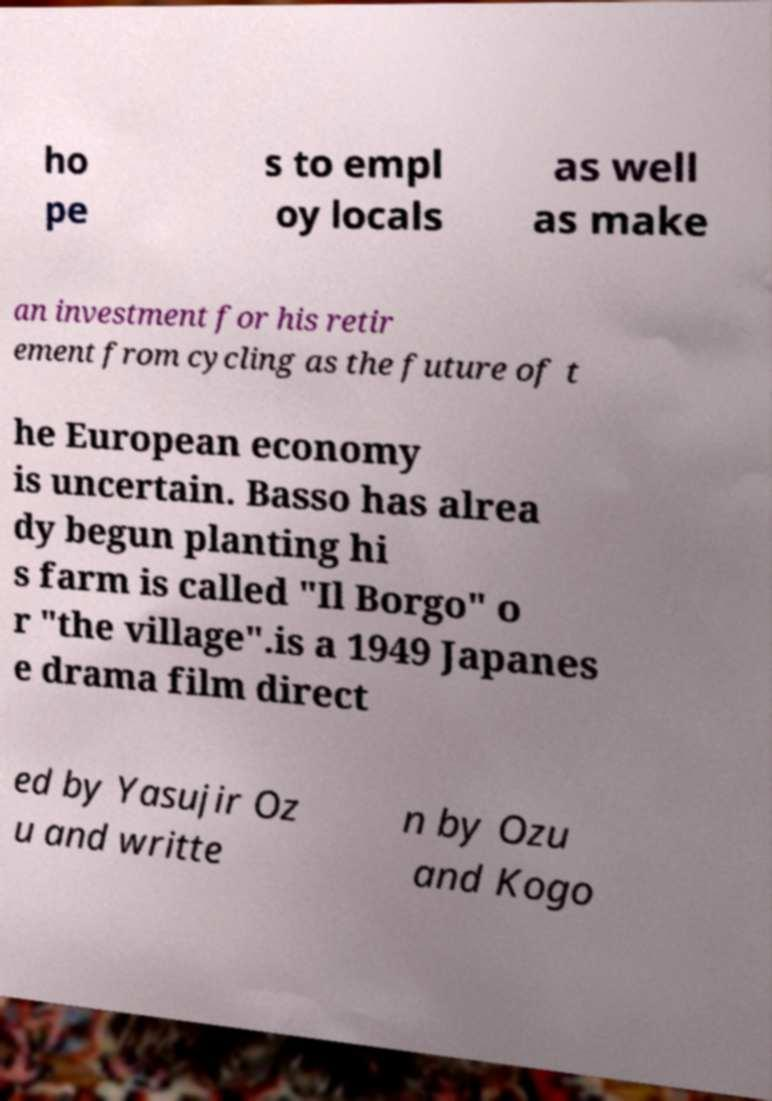There's text embedded in this image that I need extracted. Can you transcribe it verbatim? ho pe s to empl oy locals as well as make an investment for his retir ement from cycling as the future of t he European economy is uncertain. Basso has alrea dy begun planting hi s farm is called "Il Borgo" o r "the village".is a 1949 Japanes e drama film direct ed by Yasujir Oz u and writte n by Ozu and Kogo 